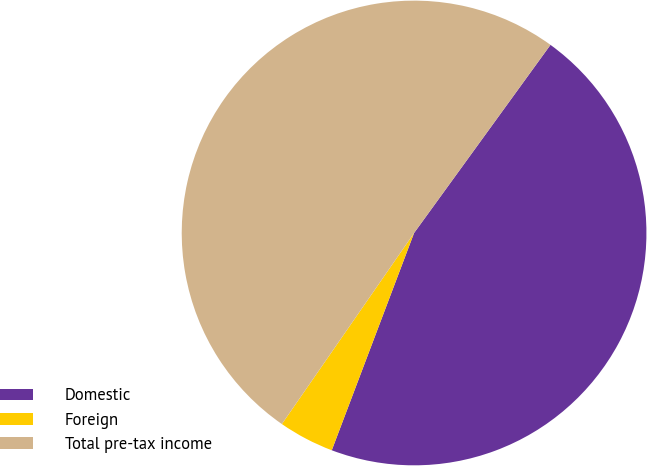Convert chart. <chart><loc_0><loc_0><loc_500><loc_500><pie_chart><fcel>Domestic<fcel>Foreign<fcel>Total pre-tax income<nl><fcel>45.78%<fcel>3.87%<fcel>50.35%<nl></chart> 